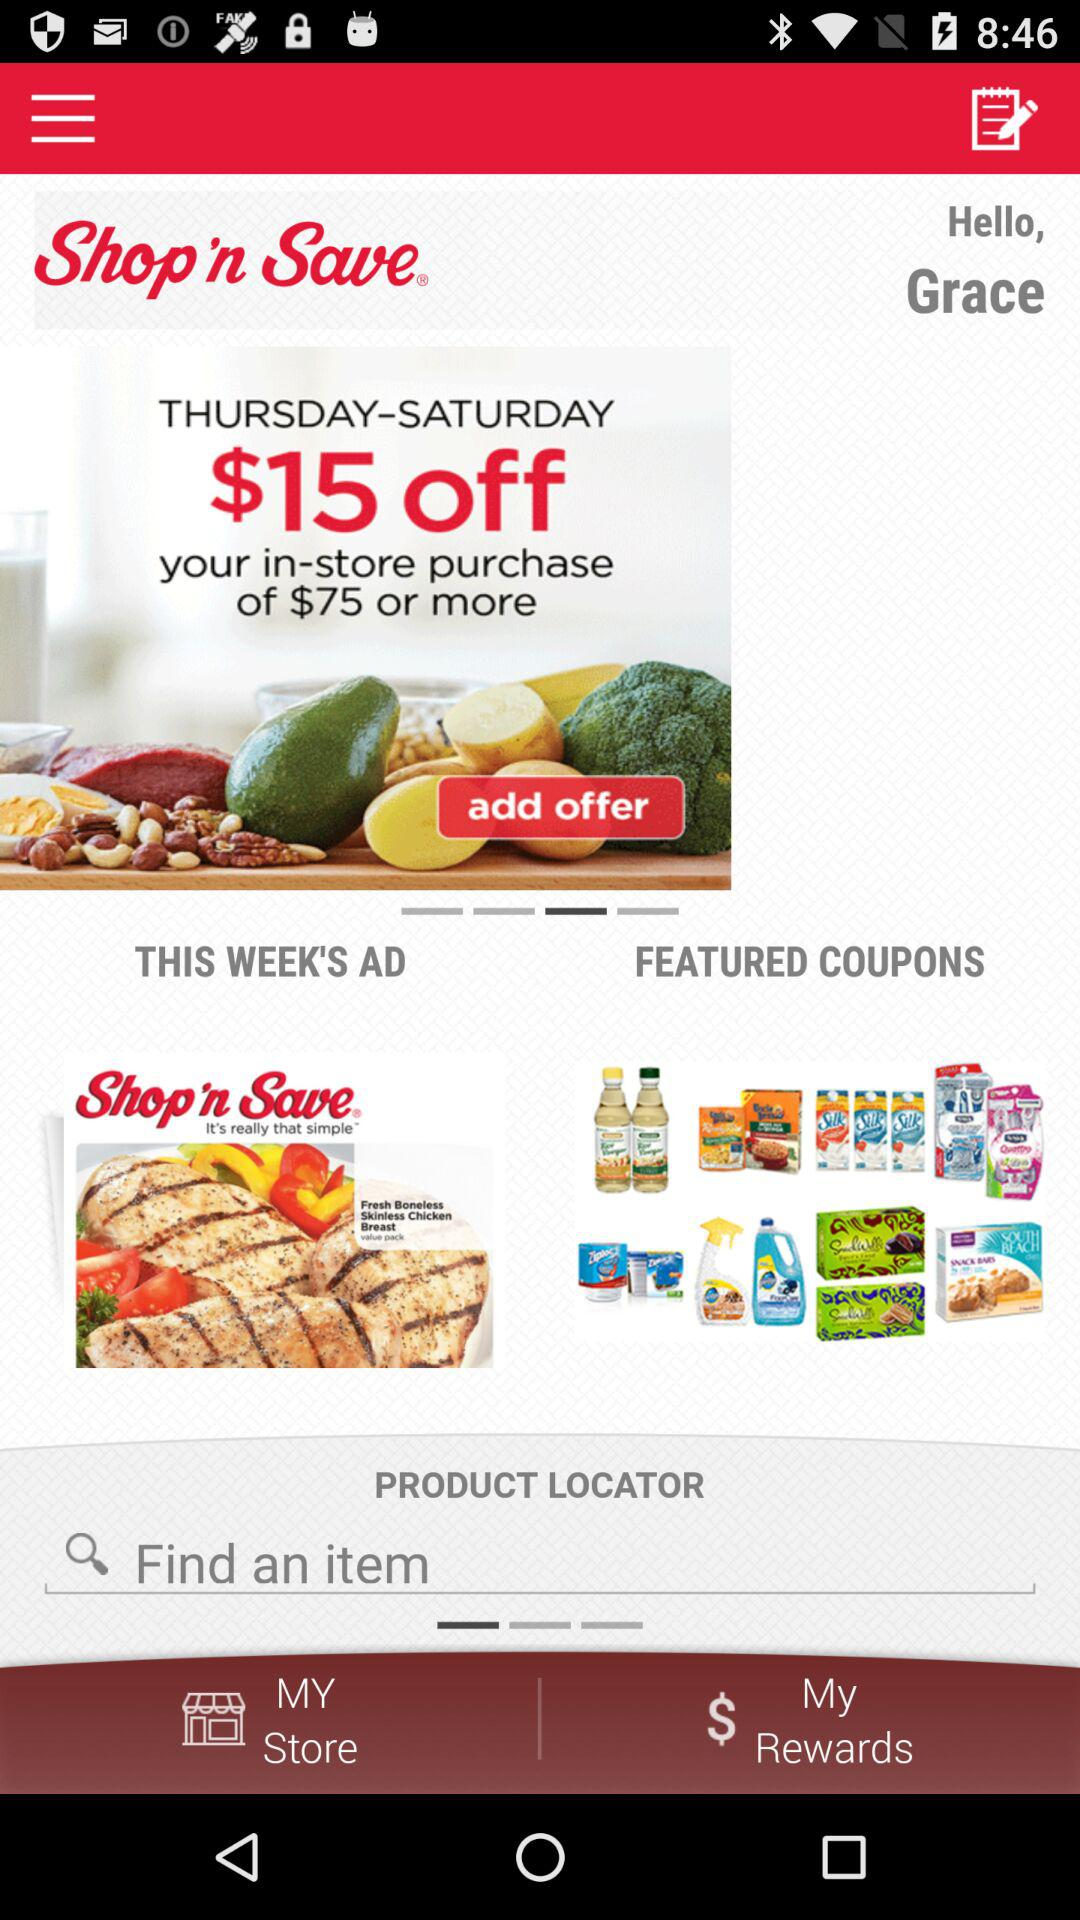What is the application name? The application name is "Shop 'n Save". 